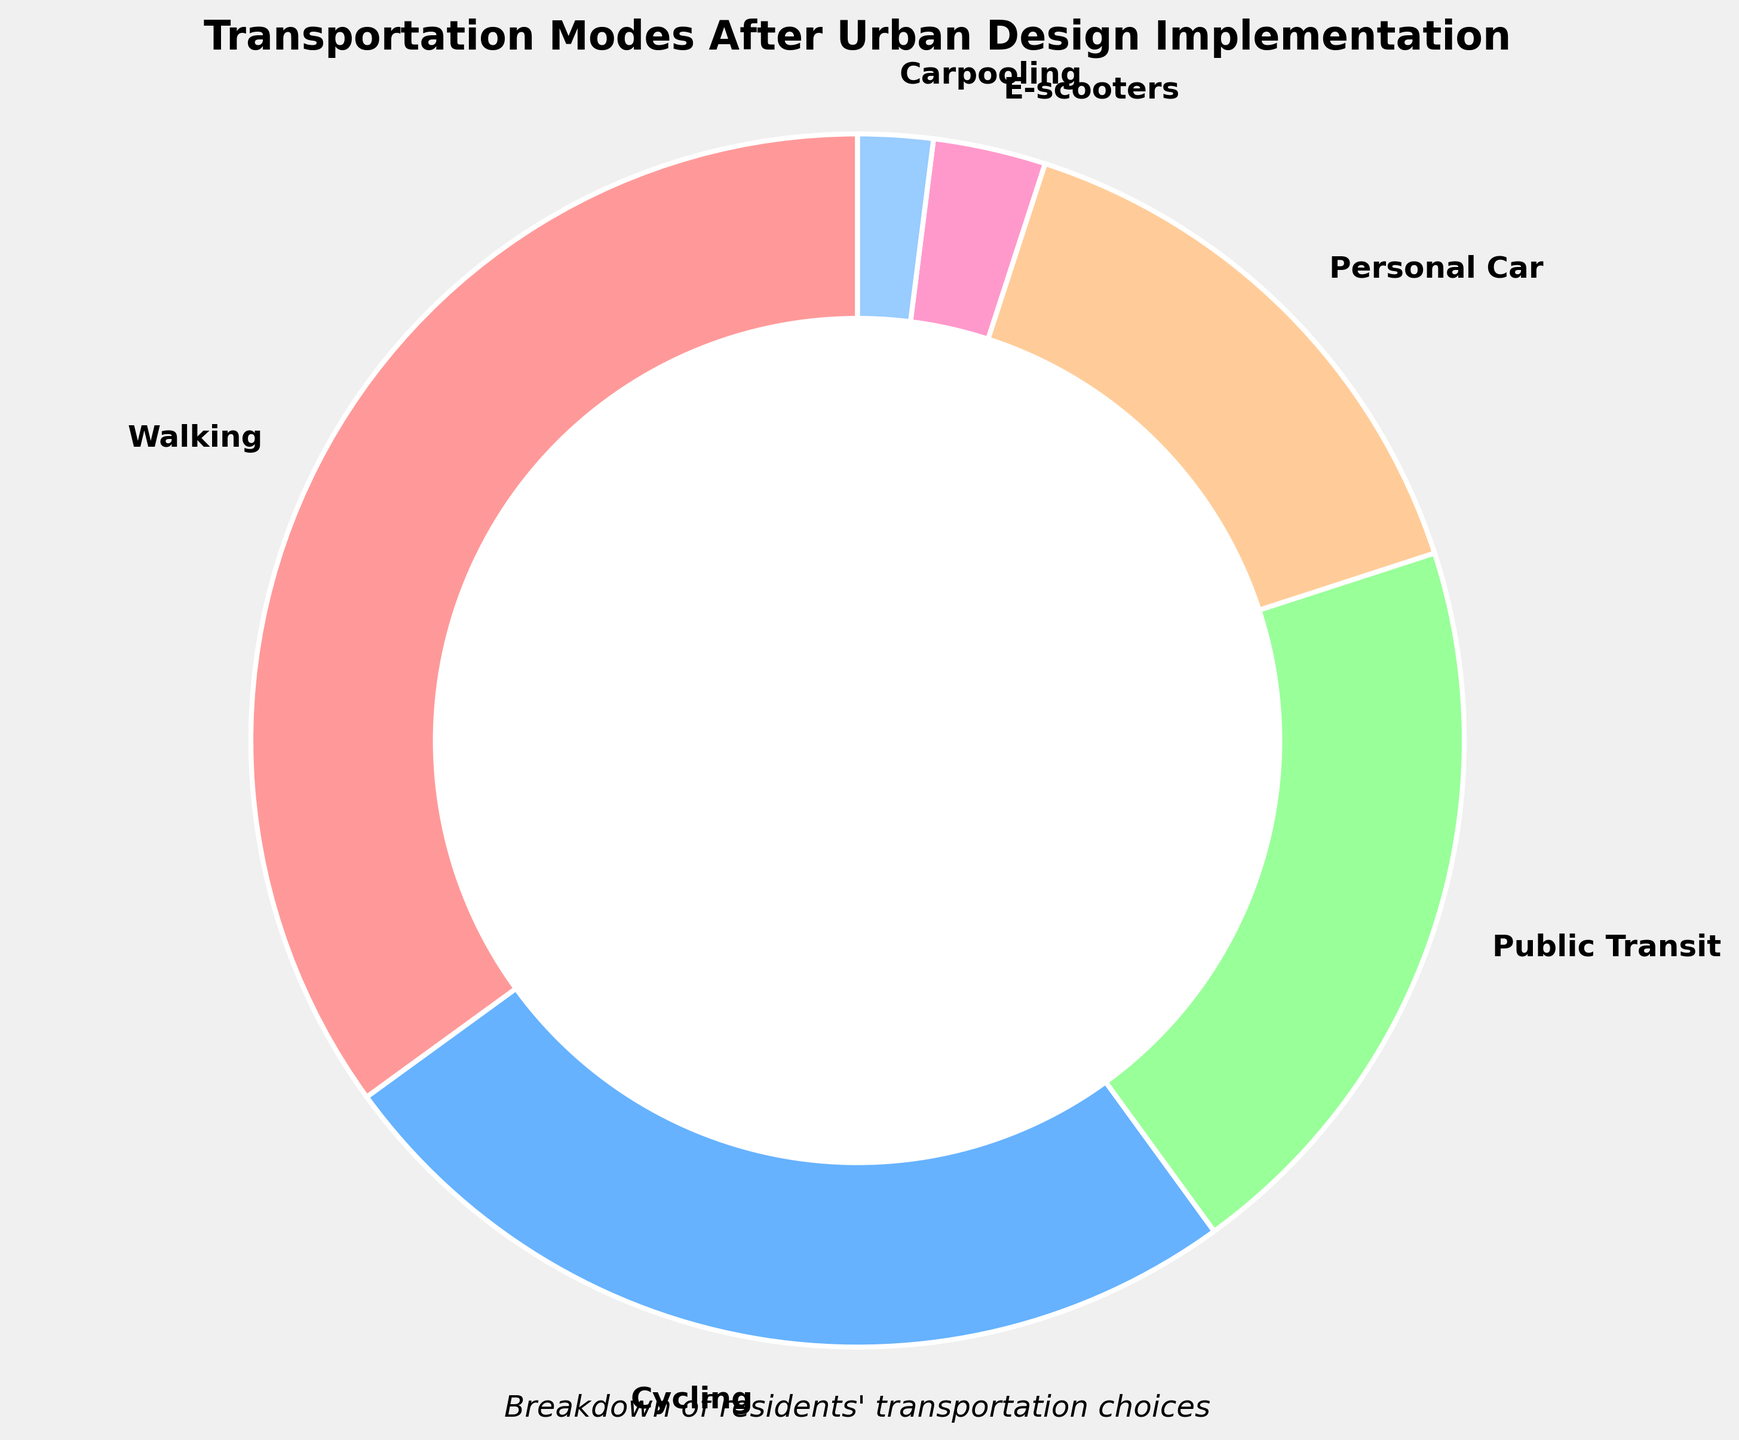Which mode of transportation is used by the highest percentage of residents? Look for the section with the largest percentage label. The "Walking" section has the largest label at 35%.
Answer: Walking Which two modes of transportation combined make up more than half of the residents' choices? Combine the percentages of "Walking" (35%) and "Cycling" (25%). Their sum is 35% + 25% = 60%, which is more than half.
Answer: Walking and Cycling What is the total percentage of residents using environmentally-friendly transportation modes (Walking, Cycling, E-scooters, Carpooling)? Add the percentages of "Walking" (35%), "Cycling" (25%), "E-scooters" (3%), and "Carpooling" (2%). The total is 35% + 25% + 3% + 2% = 65%.
Answer: 65% Which mode of transportation has the smallest percentage? Identify the smallest percentage label. The "Carpooling" section has the smallest label at 2%.
Answer: Carpooling How much more popular is Walking compared to using a Personal Car? Subtract the percentage of "Personal Car" (15%) from "Walking" (35%). The difference is 35% - 15% = 20%.
Answer: 20% What percentage of residents use mechanized modes of transportation (Public Transit, Personal Car, E-scooters)? Add the percentages of "Public Transit" (20%), "Personal Car" (15%), and "E-scooters" (3%). The total is 20% + 15% + 3% = 38%.
Answer: 38% Is Cycling more popular than using Public Transit and Personal Car combined? Compare the percentage of "Cycling" (25%) with the sum of "Public Transit" (20%) and "Personal Car" (15%). The sum is 20% + 15% = 35%, which is greater than 25%.
Answer: No Which color represents the least popular transportation mode in the pie chart? Identify the color corresponding to the "Carpooling" section by observing the chart.
Answer: Light blue By how much does the use of Public Transit exceed that of E-scooters? Subtract the percentage of "E-scooters" (3%) from "Public Transit" (20%). The difference is 20% - 3% = 17%.
Answer: 17% What is the difference in percentage points between the most and least used transportation modes? Subtract the percentage of "Carpooling" (2%) from "Walking" (35%). The difference is 35% - 2% = 33%.
Answer: 33% 